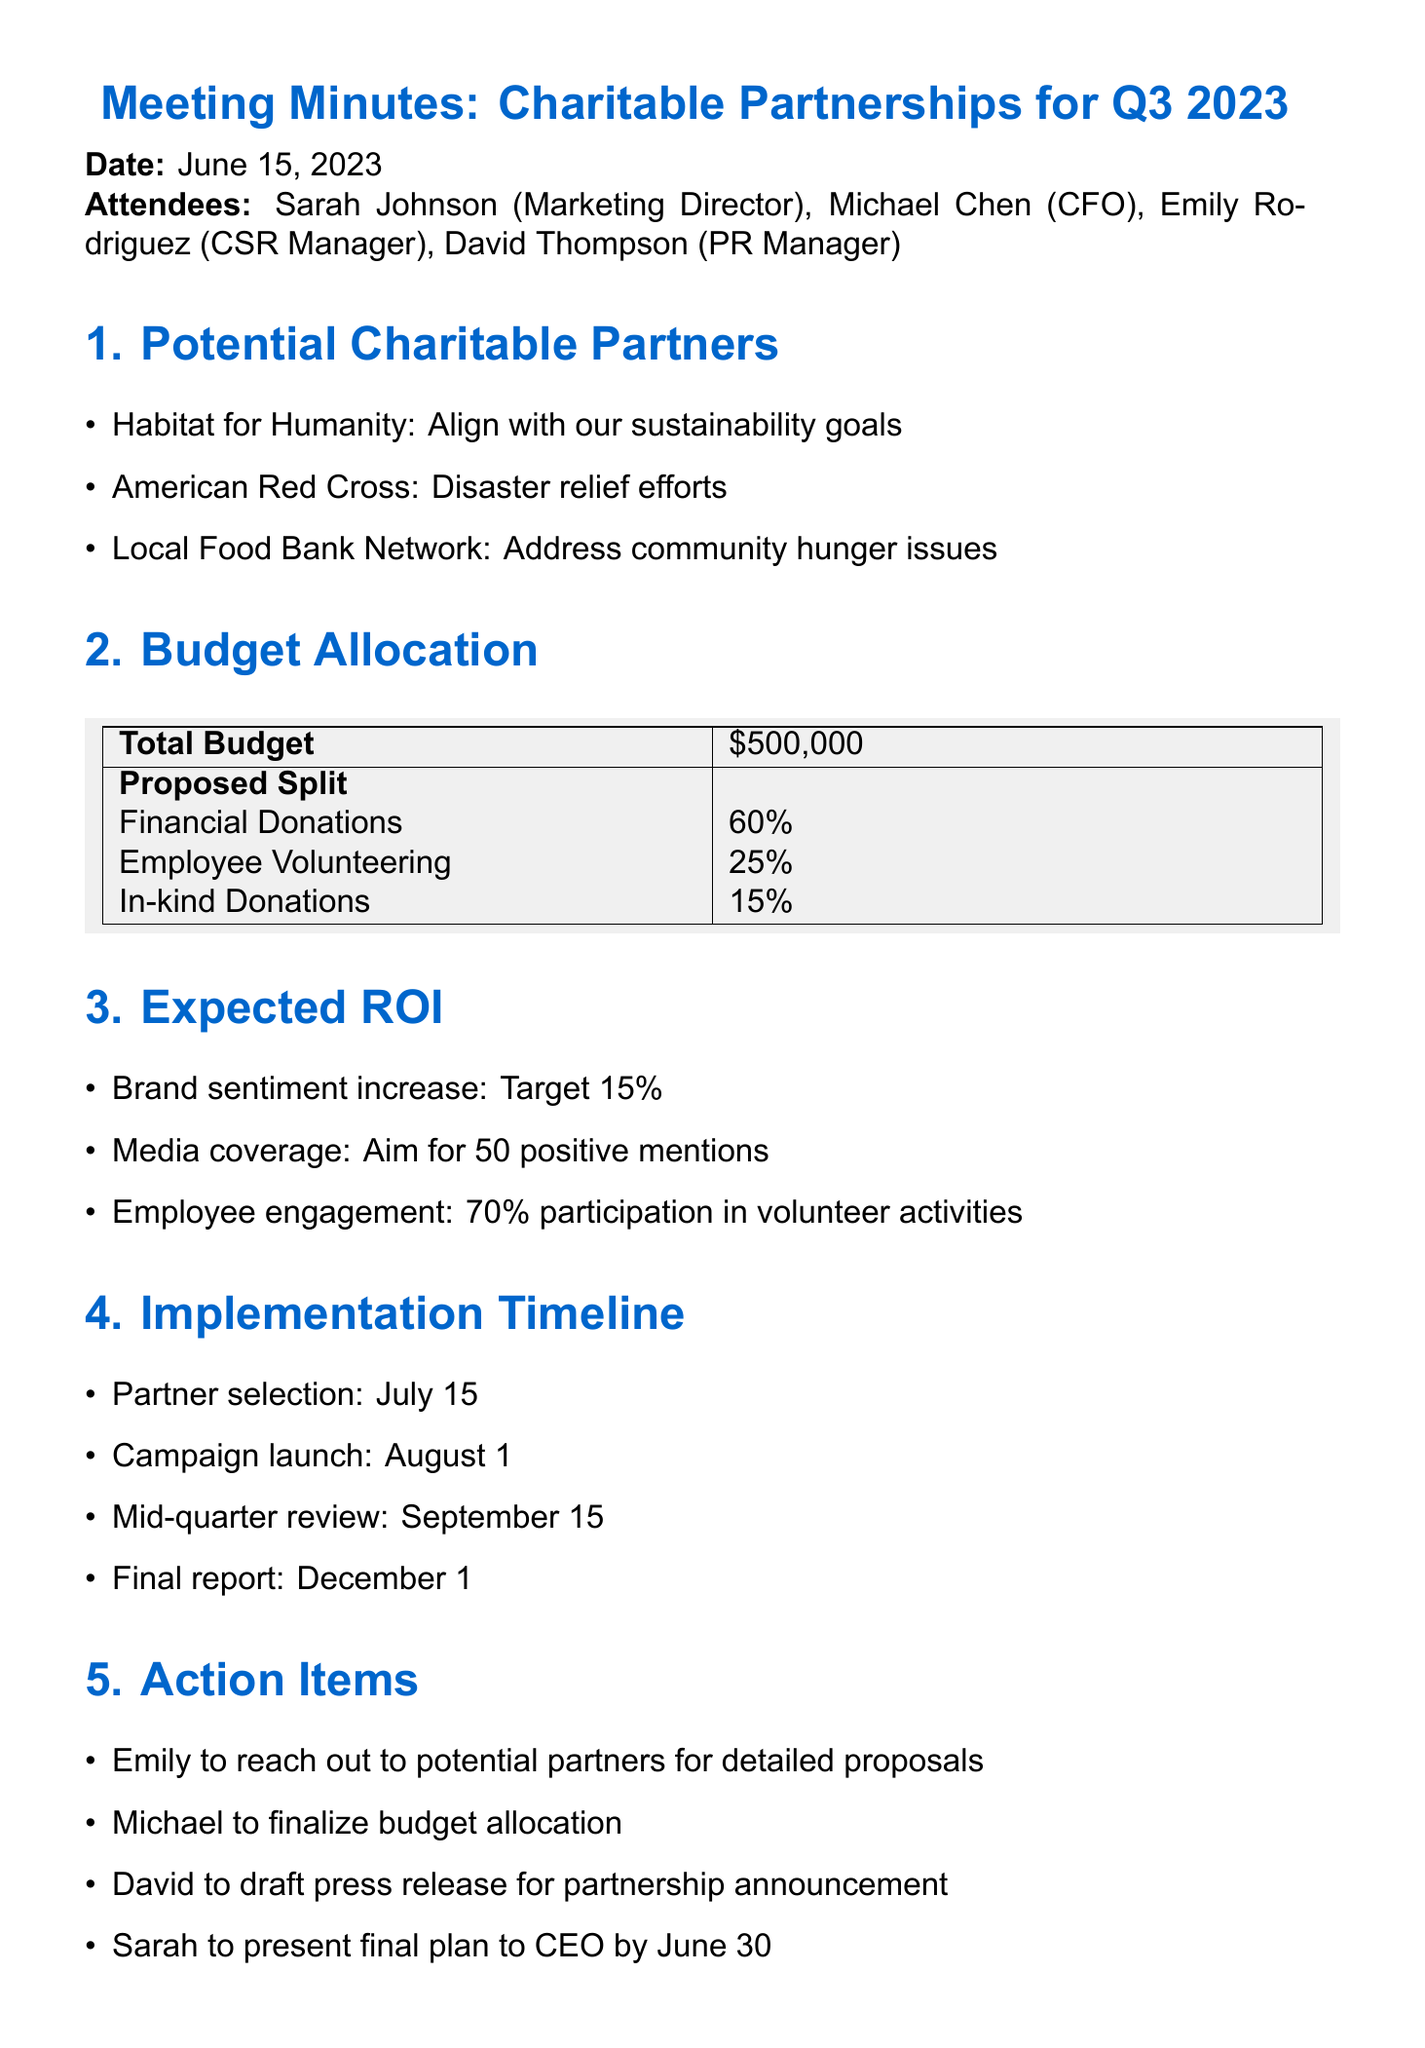What is the total budget for the charitable partnerships? The total budget mentioned in the document is explicitly stated under budget allocation.
Answer: $500,000 What is the target increase for brand sentiment? The expected ROI section specifies a target increase for brand sentiment.
Answer: 15% Who is responsible for reaching out to potential partners? This information is found under the action items section, indicating who has specific responsibilities.
Answer: Emily When is the campaign launch date? The implementation timeline clearly lists the campaign launch date as one of its milestones.
Answer: August 1 What percentage of the budget is allocated for employee volunteering? The proposed split section provides the percentage allocated for employee volunteering directly.
Answer: 25% What is the aim for media coverage mentions? The expected ROI section indicates the goal for positive media coverage mentions.
Answer: 50 positive mentions When is the final report due? This information is detailed in the implementation timeline section of the meeting minutes.
Answer: December 1 How many attendees were present at the meeting? The attendees section lists all individuals present, providing the total count.
Answer: 4 What charitable partner aligns with sustainability goals? The potential charitable partners section lists organizations and identifies which one aligns with specific company goals.
Answer: Habitat for Humanity 